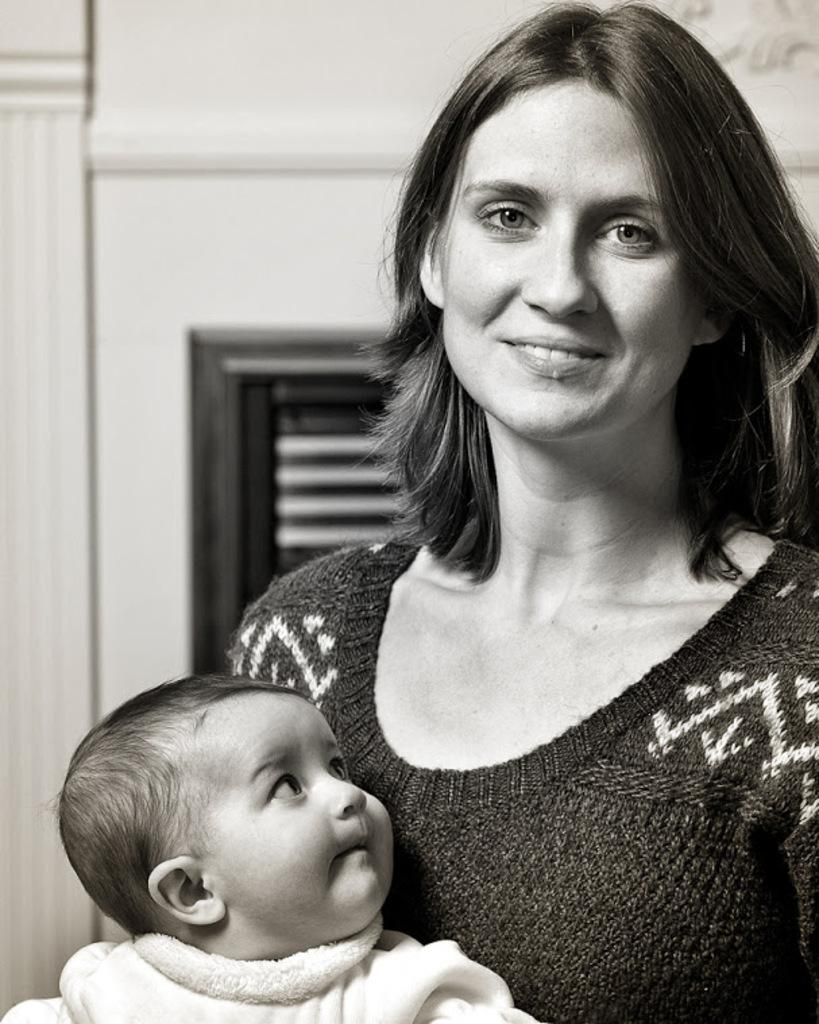Who is the main subject in the image? There is a lady in the image. Can you describe the other person in the image? There is a small baby in the image. Where are the lady and the baby located in the image? The lady and the baby are in the center of the image. What can be seen in the background of the image? There is a window on a wall in the background of the image. What type of books can be seen on the floor in the image? There are no books visible in the image; it only features a lady and a baby in the center, with a window in the background. 